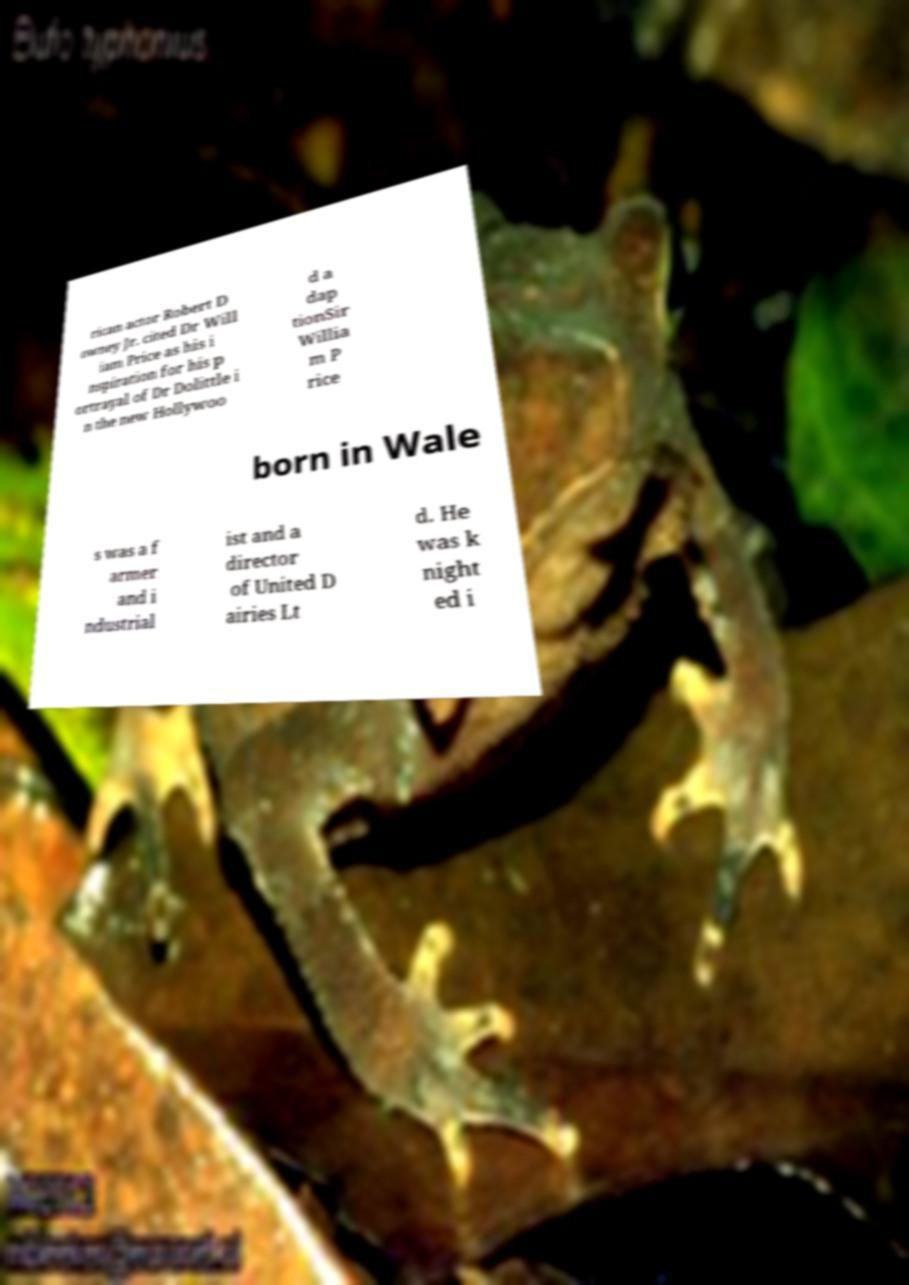I need the written content from this picture converted into text. Can you do that? rican actor Robert D owney Jr. cited Dr Will iam Price as his i nspiration for his p ortrayal of Dr Dolittle i n the new Hollywoo d a dap tionSir Willia m P rice born in Wale s was a f armer and i ndustrial ist and a director of United D airies Lt d. He was k night ed i 